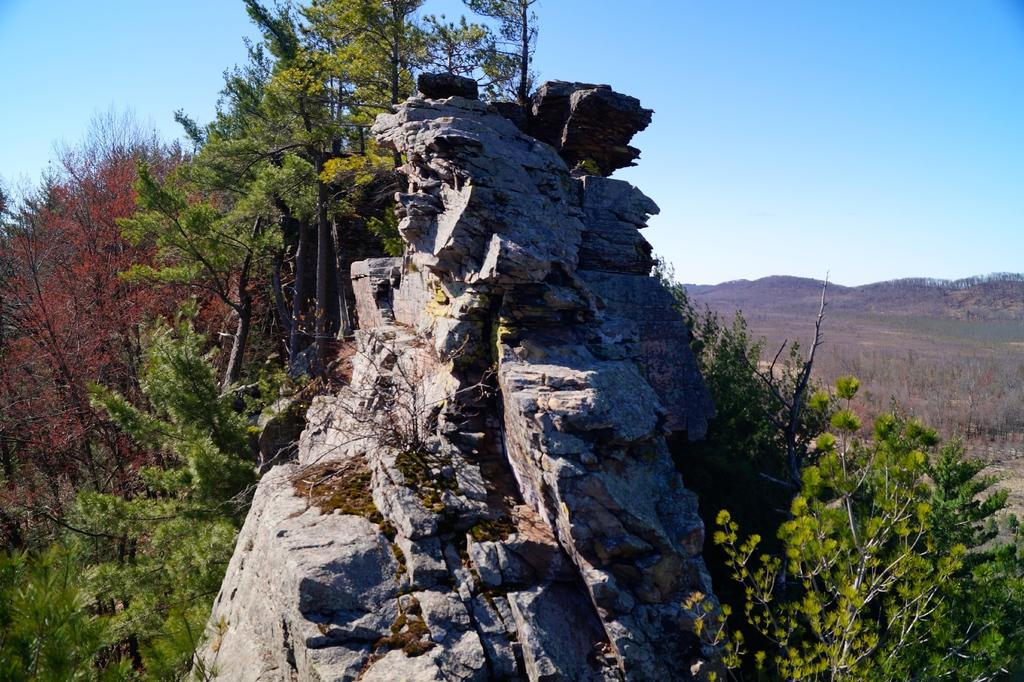What type of natural features can be seen in the image? There are rocks, trees, mountains, and grass visible in the image. What is the color of the sky in the background of the image? The sky is visible in the background of the image. What type of vegetation is present in the image? There are trees and grass visible in the image. What type of star can be seen shining on the mountains in the image? There is no star visible in the image; it only shows rocks, trees, mountains, grass, and the sky. 